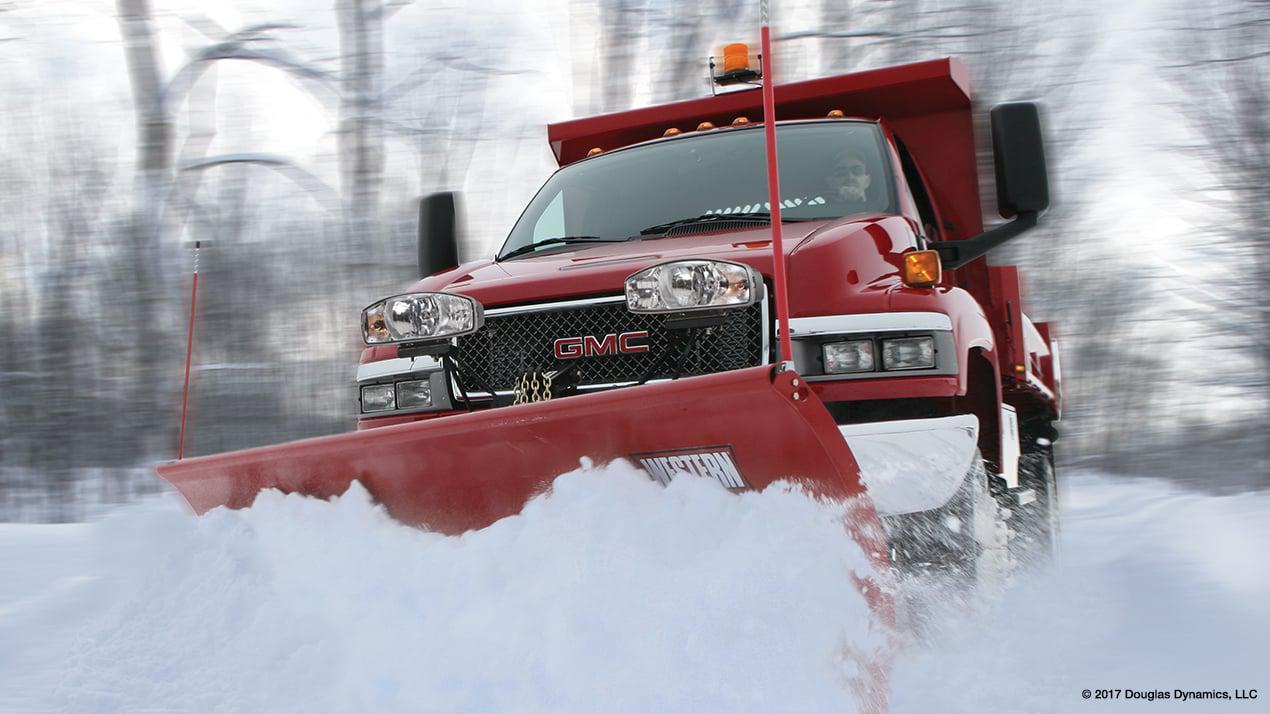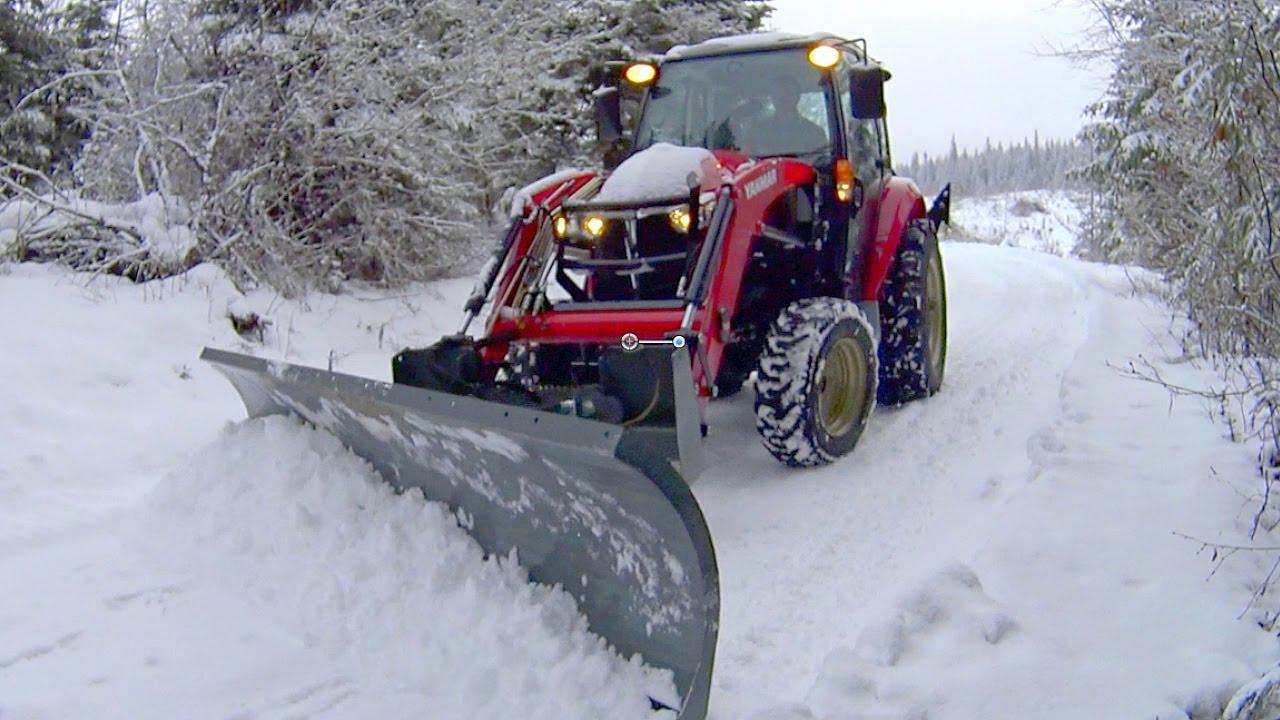The first image is the image on the left, the second image is the image on the right. For the images displayed, is the sentence "The left and right image contains the same number of orange snow trucks." factually correct? Answer yes or no. No. 